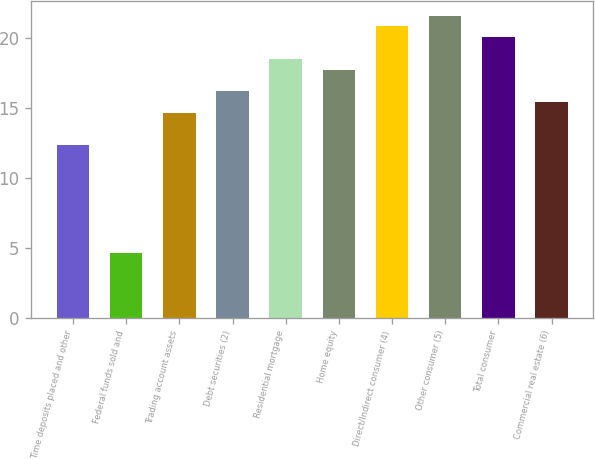<chart> <loc_0><loc_0><loc_500><loc_500><bar_chart><fcel>Time deposits placed and other<fcel>Federal funds sold and<fcel>Trading account assets<fcel>Debt securities (2)<fcel>Residential mortgage<fcel>Home equity<fcel>Direct/Indirect consumer (4)<fcel>Other consumer (5)<fcel>Total consumer<fcel>Commercial real estate (6)<nl><fcel>12.34<fcel>4.64<fcel>14.65<fcel>16.19<fcel>18.5<fcel>17.73<fcel>20.81<fcel>21.58<fcel>20.04<fcel>15.42<nl></chart> 